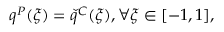Convert formula to latex. <formula><loc_0><loc_0><loc_500><loc_500>\begin{array} { r } { q ^ { P } ( \xi ) = \check { q } ^ { C } ( \xi ) , \forall \xi \in [ - 1 , 1 ] , } \end{array}</formula> 